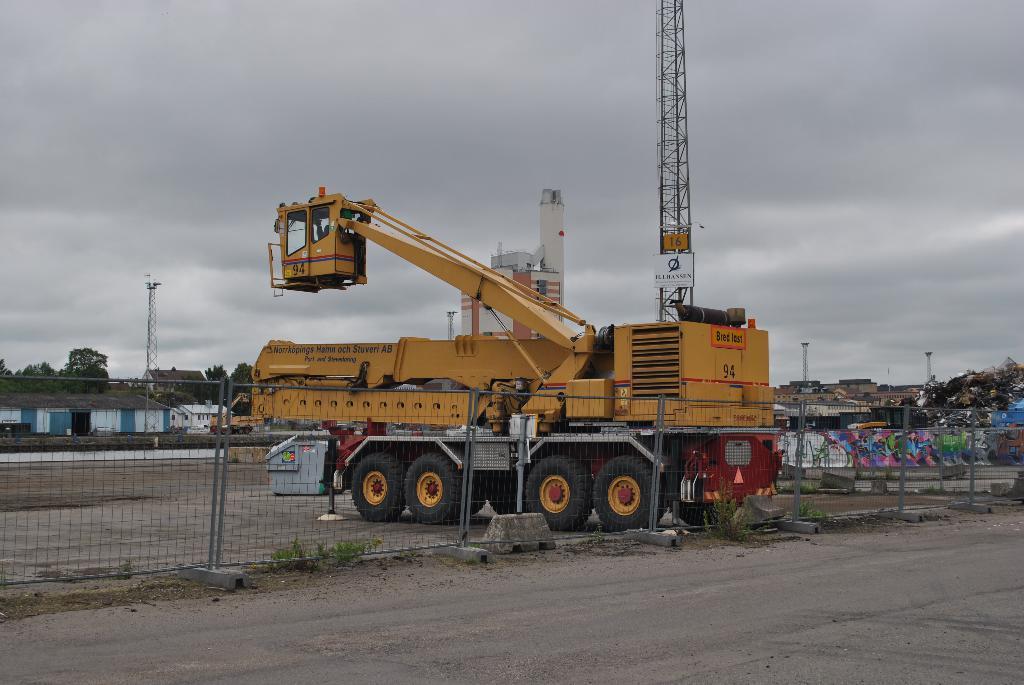Describe this image in one or two sentences. In this image there is a vehicle. Behind the vehicle there is some object. There is a tower. In front of the vehicle there is a metal fence. On the right side of the image there is a painting on the wall. In the background of the image there are buildings, trees, towers and sky. 